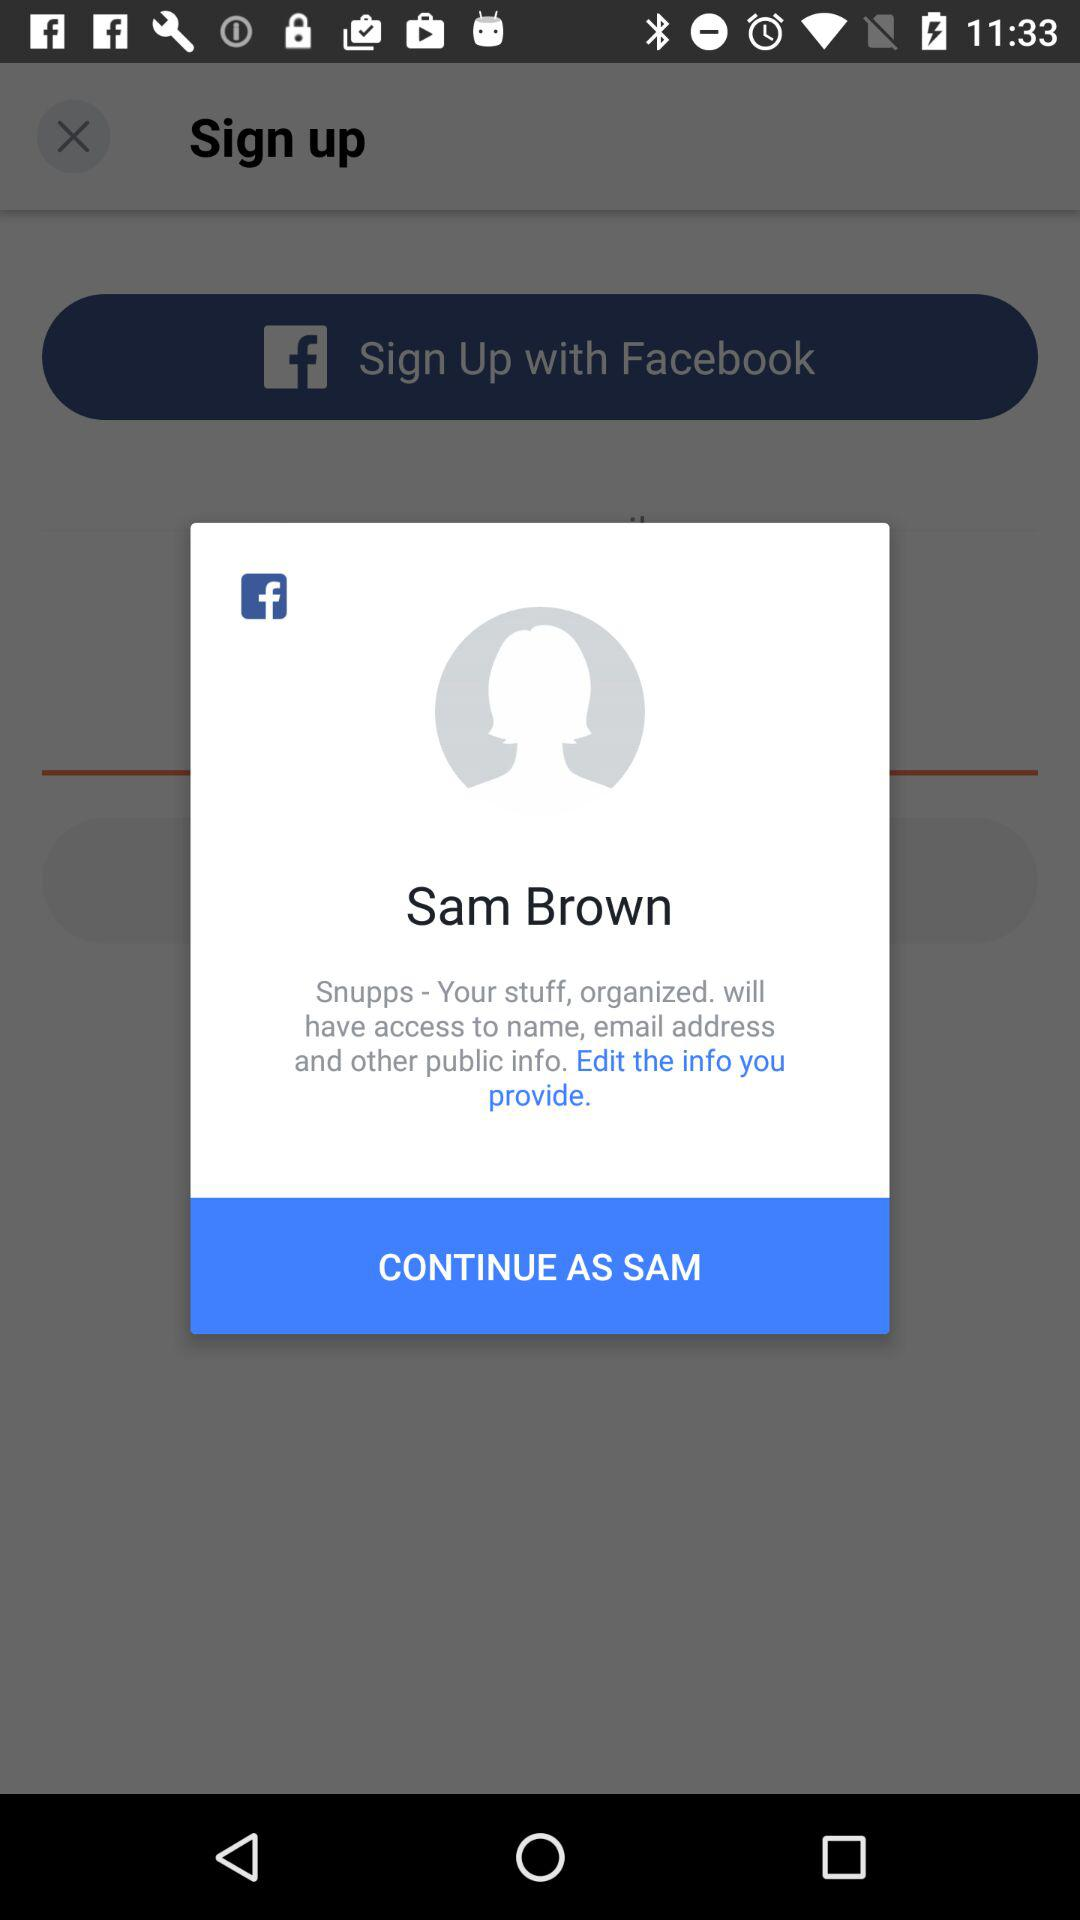What's the username? The username is Sam Brown. 